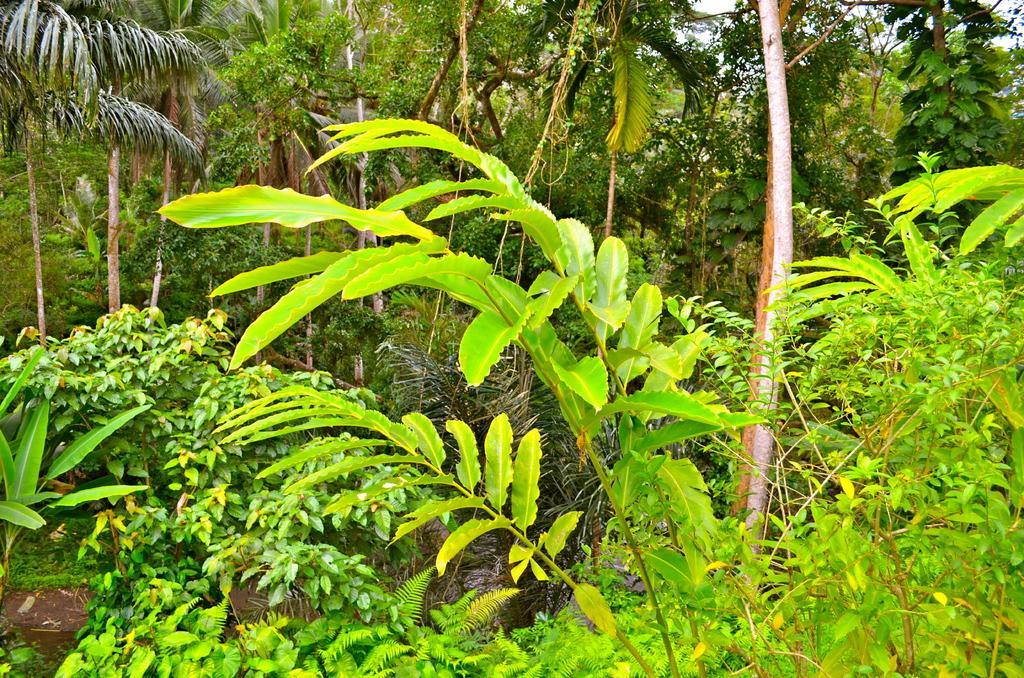In one or two sentences, can you explain what this image depicts? This picture contains many trees. This picture might be clicked in the forest or in the garden. 